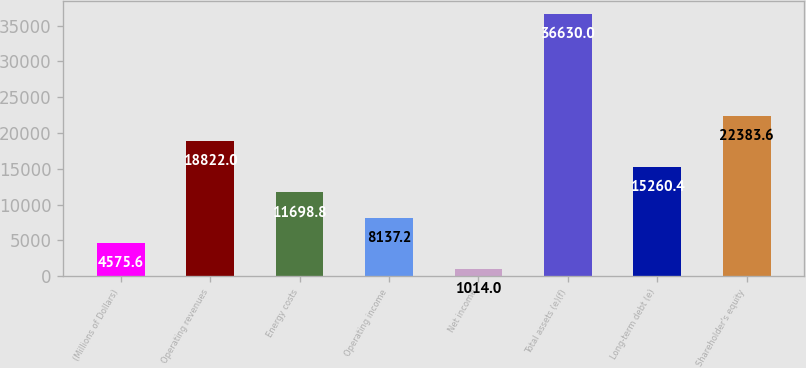Convert chart to OTSL. <chart><loc_0><loc_0><loc_500><loc_500><bar_chart><fcel>(Millions of Dollars)<fcel>Operating revenues<fcel>Energy costs<fcel>Operating income<fcel>Net income<fcel>Total assets (e)(f)<fcel>Long-term debt (e)<fcel>Shareholder's equity<nl><fcel>4575.6<fcel>18822<fcel>11698.8<fcel>8137.2<fcel>1014<fcel>36630<fcel>15260.4<fcel>22383.6<nl></chart> 